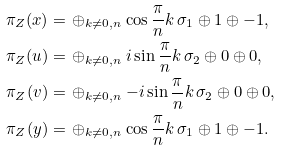<formula> <loc_0><loc_0><loc_500><loc_500>\pi _ { Z } ( x ) = & \, \oplus _ { k \neq 0 , n } \cos \frac { \pi } { n } k \, \sigma _ { 1 } \oplus 1 \oplus - 1 , \\ \pi _ { Z } ( u ) = & \, \oplus _ { k \neq 0 , n } i \sin \frac { \pi } { n } k \, \sigma _ { 2 } \oplus 0 \oplus 0 , \\ \pi _ { Z } ( v ) = & \, \oplus _ { k \neq 0 , n } - i \sin \frac { \pi } { n } k \, \sigma _ { 2 } \oplus 0 \oplus 0 , \\ \pi _ { Z } ( y ) = & \, \oplus _ { k \neq 0 , n } \cos \frac { \pi } { n } k \, \sigma _ { 1 } \oplus 1 \oplus - 1 .</formula> 